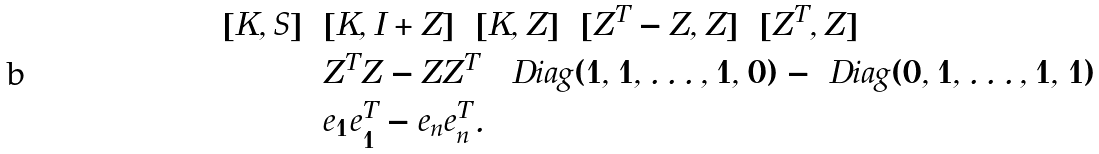<formula> <loc_0><loc_0><loc_500><loc_500>[ K , S ] & = [ K , I + Z ] = [ K , Z ] = [ Z ^ { T } - Z , Z ] = [ Z ^ { T } , Z ] \\ & = Z ^ { T } Z - Z Z ^ { T } = \ D i a g ( 1 , 1 , \dots , 1 , 0 ) - \ D i a g ( 0 , 1 , \dots , 1 , 1 ) \\ & = e _ { 1 } e _ { 1 } ^ { T } - e _ { n } e _ { n } ^ { T } .</formula> 